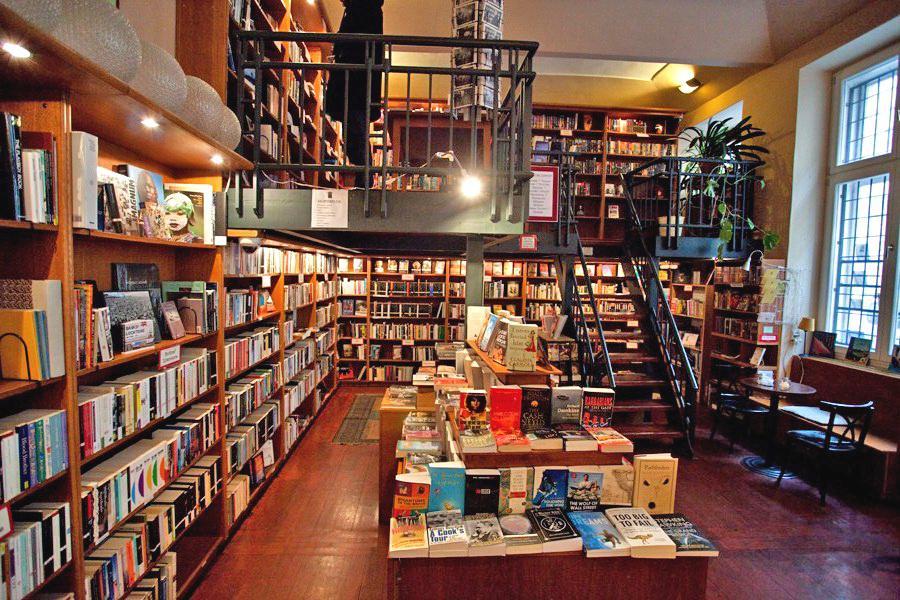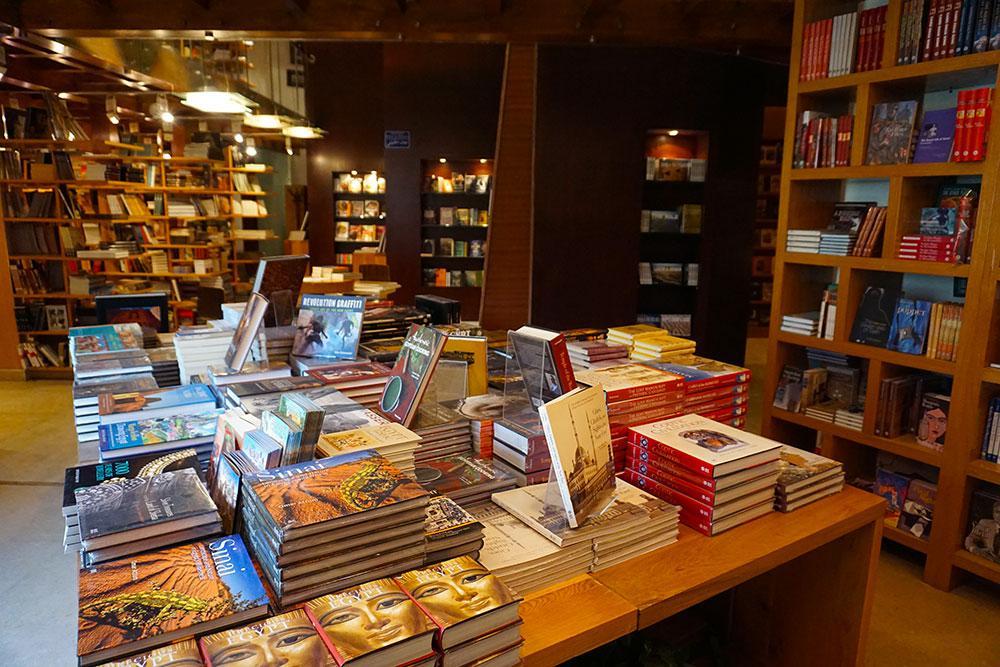The first image is the image on the left, the second image is the image on the right. Analyze the images presented: Is the assertion "One bookstore interior shows central table displays flanked by empty aisles, and the other interior shows a table display with upright and flat books." valid? Answer yes or no. Yes. 